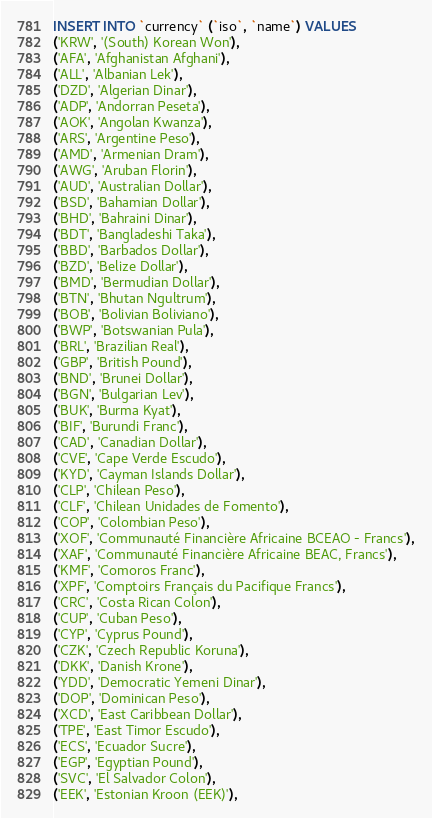Convert code to text. <code><loc_0><loc_0><loc_500><loc_500><_SQL_>INSERT INTO `currency` (`iso`, `name`) VALUES
('KRW', '(South) Korean Won'),
('AFA', 'Afghanistan Afghani'),
('ALL', 'Albanian Lek'),
('DZD', 'Algerian Dinar'),
('ADP', 'Andorran Peseta'),
('AOK', 'Angolan Kwanza'),
('ARS', 'Argentine Peso'),
('AMD', 'Armenian Dram'),
('AWG', 'Aruban Florin'),
('AUD', 'Australian Dollar'),
('BSD', 'Bahamian Dollar'),
('BHD', 'Bahraini Dinar'),
('BDT', 'Bangladeshi Taka'),
('BBD', 'Barbados Dollar'),
('BZD', 'Belize Dollar'),
('BMD', 'Bermudian Dollar'),
('BTN', 'Bhutan Ngultrum'),
('BOB', 'Bolivian Boliviano'),
('BWP', 'Botswanian Pula'),
('BRL', 'Brazilian Real'),
('GBP', 'British Pound'),
('BND', 'Brunei Dollar'),
('BGN', 'Bulgarian Lev'),
('BUK', 'Burma Kyat'),
('BIF', 'Burundi Franc'),
('CAD', 'Canadian Dollar'),
('CVE', 'Cape Verde Escudo'),
('KYD', 'Cayman Islands Dollar'),
('CLP', 'Chilean Peso'),
('CLF', 'Chilean Unidades de Fomento'),
('COP', 'Colombian Peso'),
('XOF', 'Communauté Financière Africaine BCEAO - Francs'),
('XAF', 'Communauté Financière Africaine BEAC, Francs'),
('KMF', 'Comoros Franc'),
('XPF', 'Comptoirs Français du Pacifique Francs'),
('CRC', 'Costa Rican Colon'),
('CUP', 'Cuban Peso'),
('CYP', 'Cyprus Pound'),
('CZK', 'Czech Republic Koruna'),
('DKK', 'Danish Krone'),
('YDD', 'Democratic Yemeni Dinar'),
('DOP', 'Dominican Peso'),
('XCD', 'East Caribbean Dollar'),
('TPE', 'East Timor Escudo'),
('ECS', 'Ecuador Sucre'),
('EGP', 'Egyptian Pound'),
('SVC', 'El Salvador Colon'),
('EEK', 'Estonian Kroon (EEK)'),</code> 